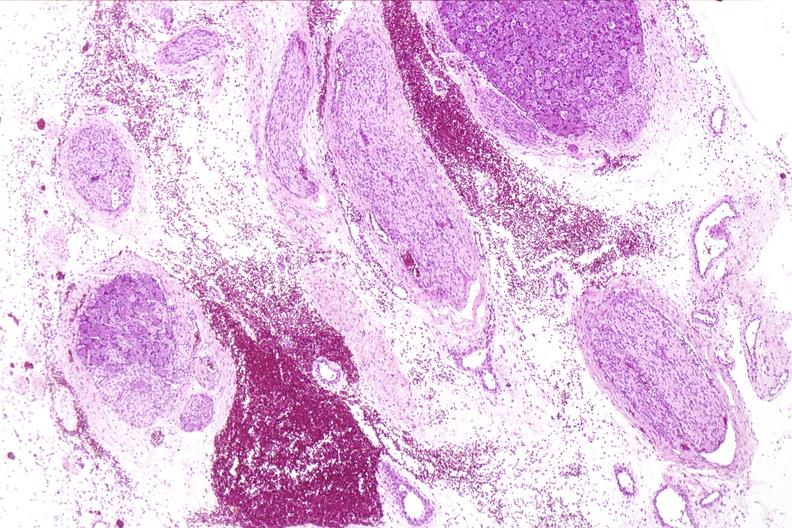what does this image show?
Answer the question using a single word or phrase. Neural tube defect 